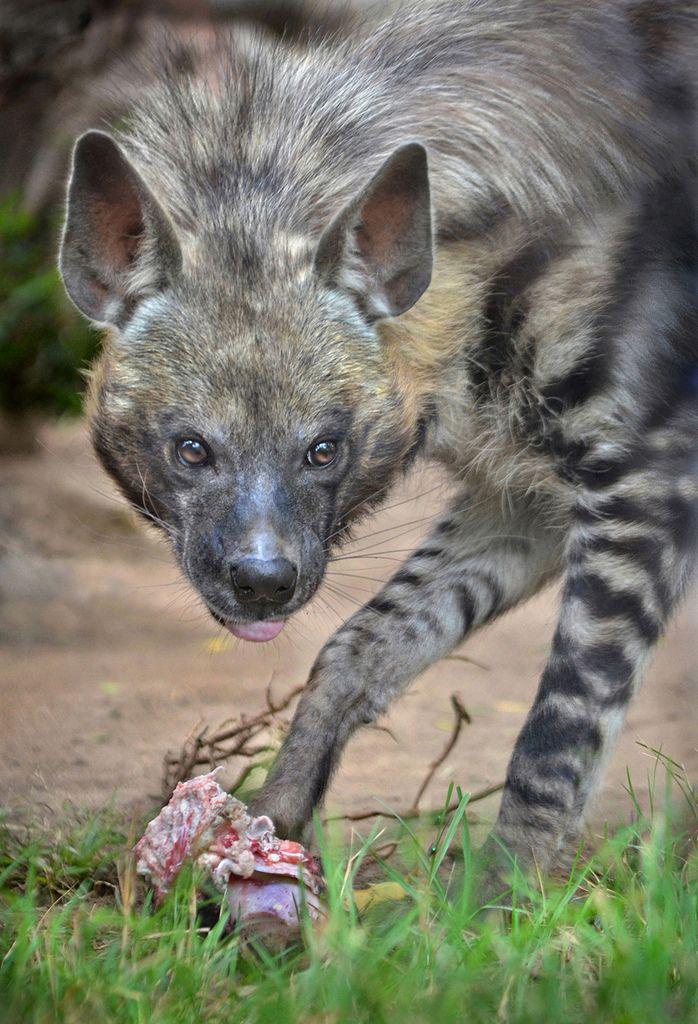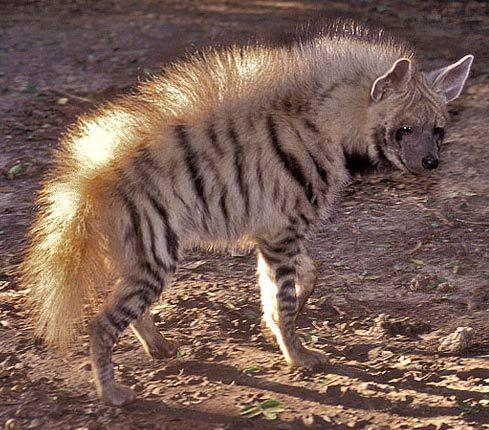The first image is the image on the left, the second image is the image on the right. For the images displayed, is the sentence "At least one hyena is laying down." factually correct? Answer yes or no. No. The first image is the image on the left, the second image is the image on the right. For the images displayed, is the sentence "No image contains more than one animal, and one image features an adult hyena in a standing pose with its body turned rightward." factually correct? Answer yes or no. Yes. 